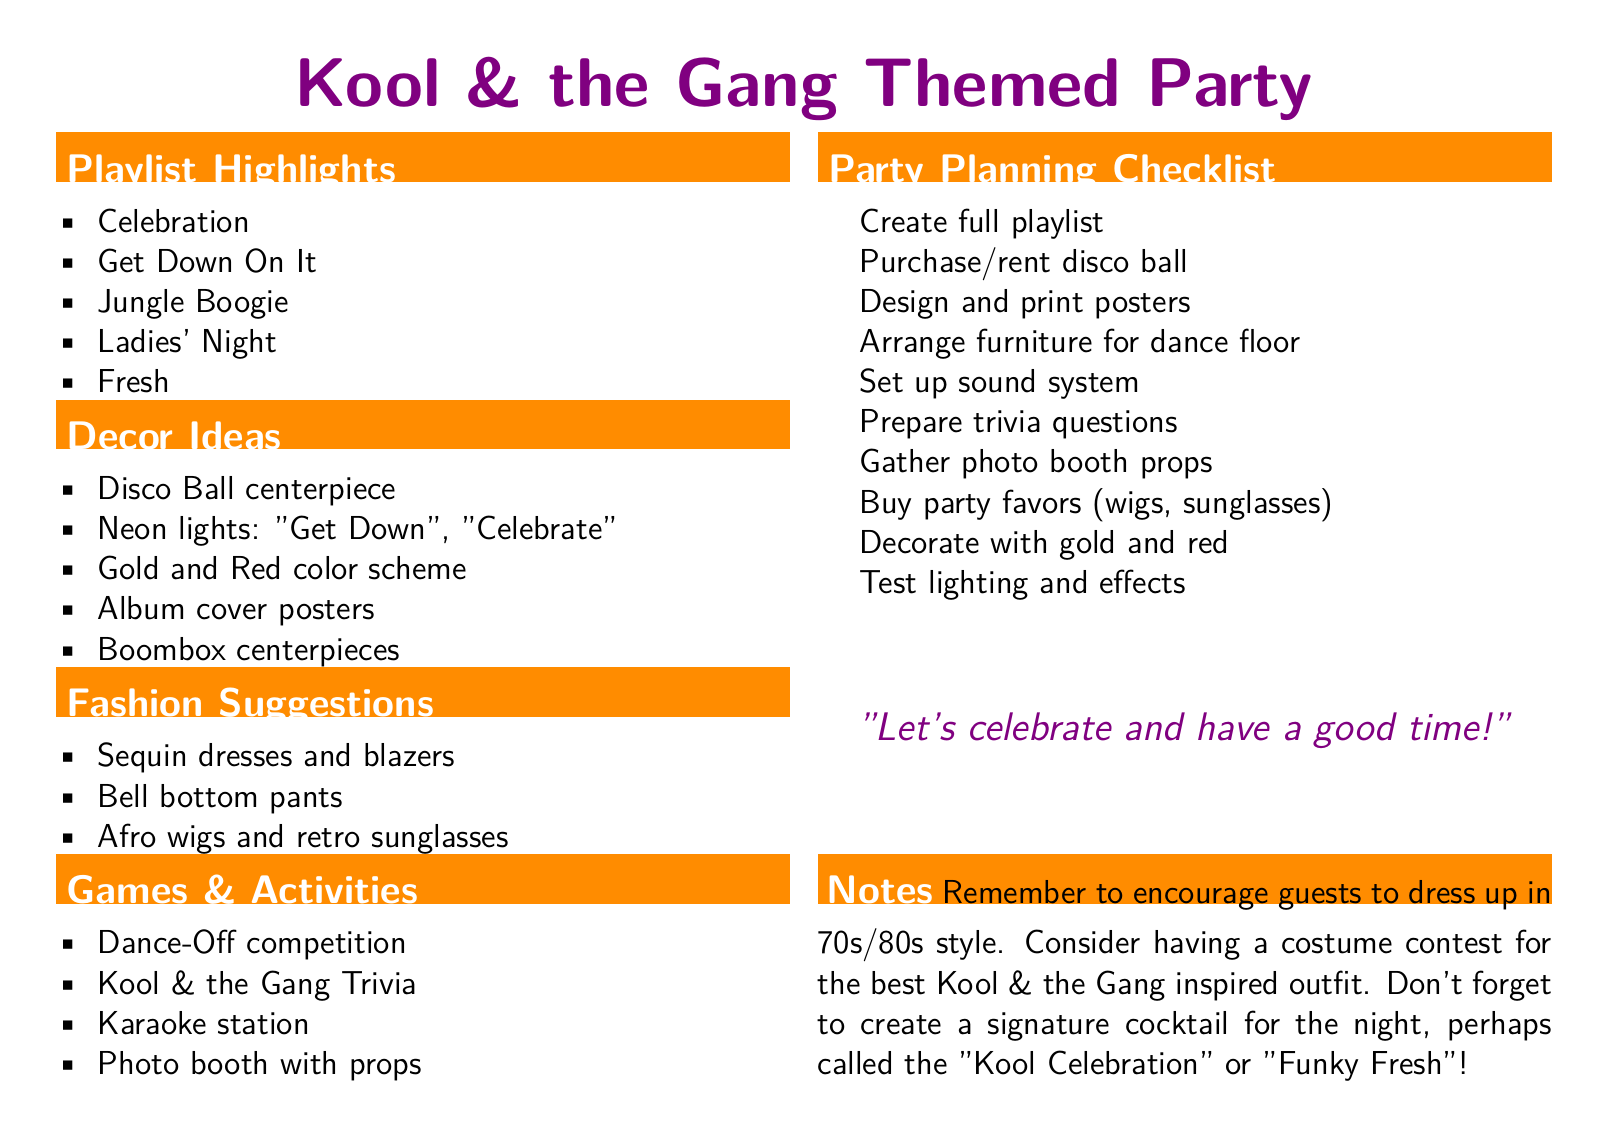What are the five songs listed in the playlist highlights? The document lists five specific songs as part of the playlist highlights.
Answer: Celebration, Get Down On It, Jungle Boogie, Ladies' Night, Fresh What type of lighting is suggested for decor? The document mentions lighting specifically designed to add ambiance to the party decor.
Answer: Neon lights What is one fashion suggestion for attendees? The document provides various fashion suggestions tailored to the theme.
Answer: Sequin dresses What activity involves competition among guests? The document lists several games and activities for engagement at the party.
Answer: Dance-Off competition What color scheme is recommended for the decorations? The document states a specific color scheme to be used for decor to align with the theme.
Answer: Gold and Red How many items are in the Party Planning Checklist? The document includes a checklist for tasks to prepare for the party, listing each item clearly.
Answer: Ten What unique drink name is suggested for the party? The document includes ideas for party-themed cocktails to enhance the festivities.
Answer: Kool Celebration What type of contest is suggested for outfits? The document mentions an activity related to costumes guests might wear, enhancing the party's theme.
Answer: Costume contest 